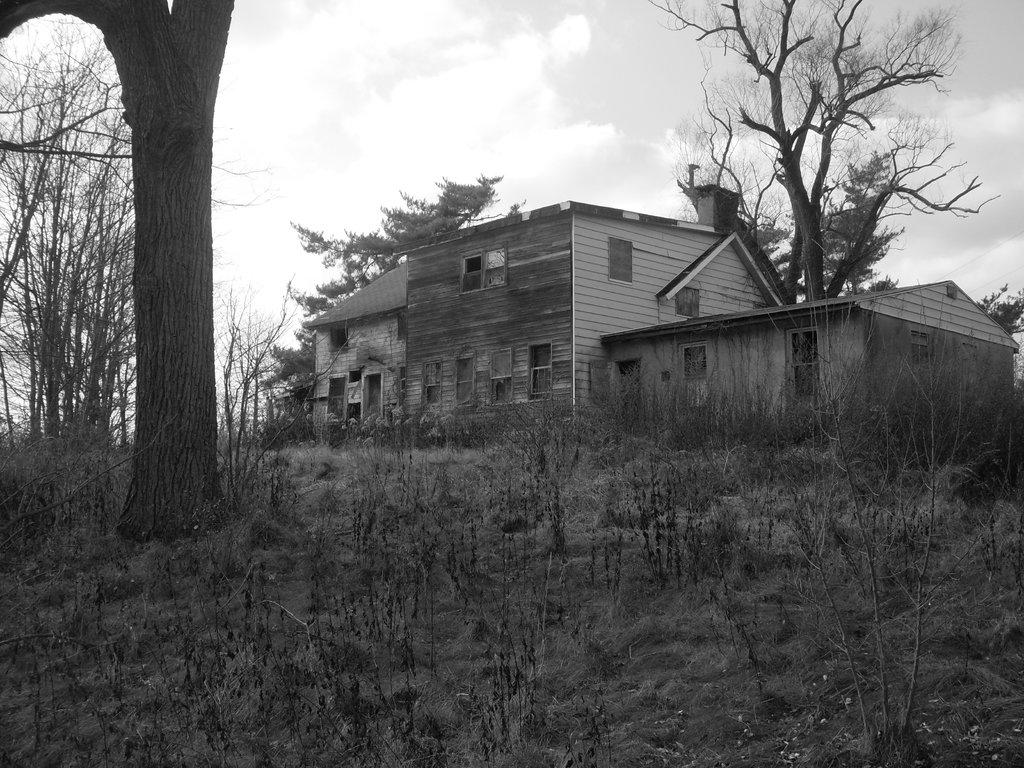What is the color scheme of the image? The image is black and white. What type of structures can be seen in the image? There are houses in the image. What other natural elements are present in the image? There are trees in the image. What covers the ground in the image? The ground is covered with plants. What can be seen in the sky in the image? There are clouds in the sky. Where is the cow grazing in the image? There is no cow present in the image. How many bulbs are illuminating the area in the image? There are no bulbs visible in the image. 